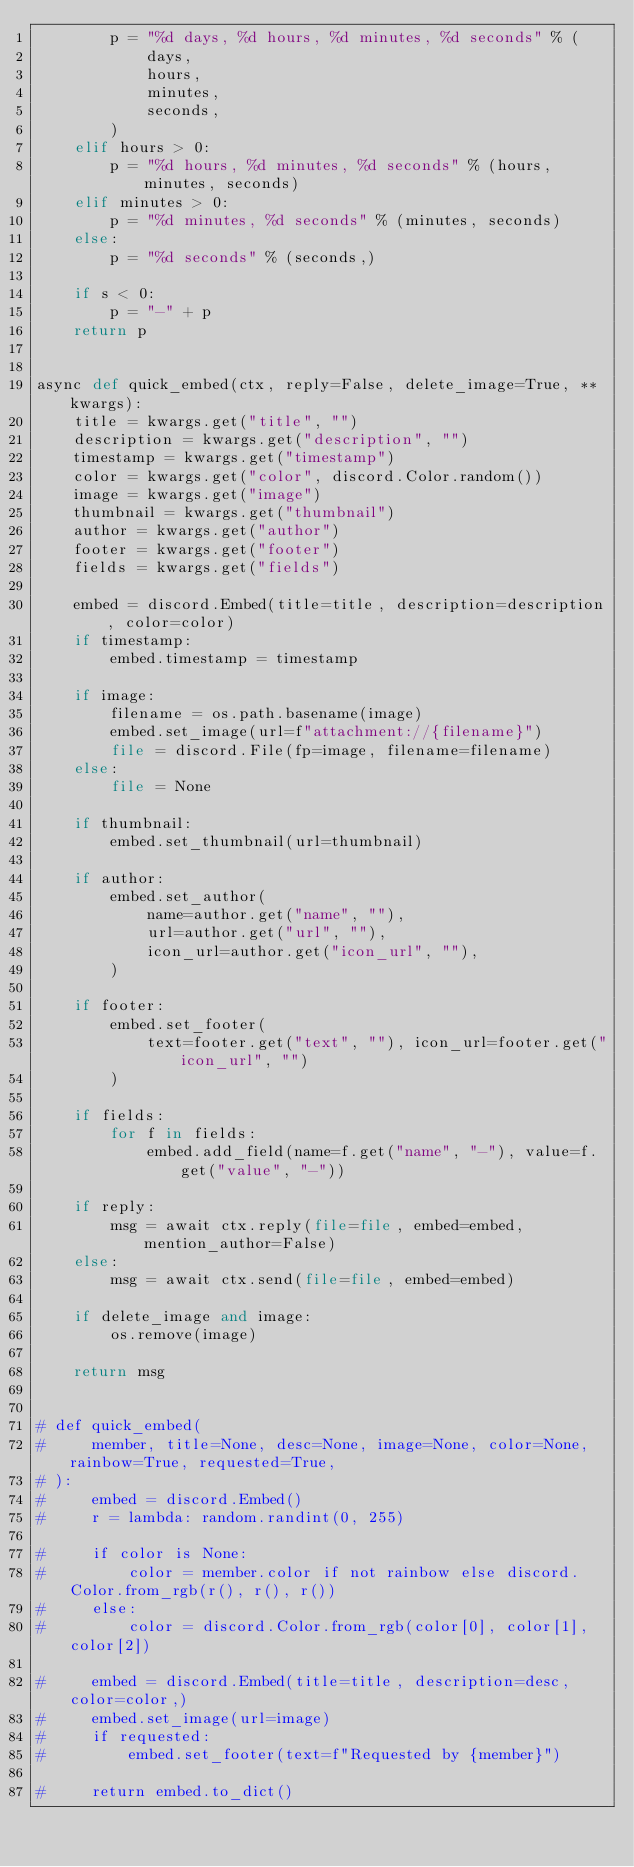<code> <loc_0><loc_0><loc_500><loc_500><_Python_>        p = "%d days, %d hours, %d minutes, %d seconds" % (
            days,
            hours,
            minutes,
            seconds,
        )
    elif hours > 0:
        p = "%d hours, %d minutes, %d seconds" % (hours, minutes, seconds)
    elif minutes > 0:
        p = "%d minutes, %d seconds" % (minutes, seconds)
    else:
        p = "%d seconds" % (seconds,)

    if s < 0:
        p = "-" + p
    return p


async def quick_embed(ctx, reply=False, delete_image=True, **kwargs):
    title = kwargs.get("title", "")
    description = kwargs.get("description", "")
    timestamp = kwargs.get("timestamp")
    color = kwargs.get("color", discord.Color.random())
    image = kwargs.get("image")
    thumbnail = kwargs.get("thumbnail")
    author = kwargs.get("author")
    footer = kwargs.get("footer")
    fields = kwargs.get("fields")

    embed = discord.Embed(title=title, description=description, color=color)
    if timestamp:
        embed.timestamp = timestamp

    if image:
        filename = os.path.basename(image)
        embed.set_image(url=f"attachment://{filename}")
        file = discord.File(fp=image, filename=filename)
    else:
        file = None

    if thumbnail:
        embed.set_thumbnail(url=thumbnail)

    if author:
        embed.set_author(
            name=author.get("name", ""),
            url=author.get("url", ""),
            icon_url=author.get("icon_url", ""),
        )

    if footer:
        embed.set_footer(
            text=footer.get("text", ""), icon_url=footer.get("icon_url", "")
        )

    if fields:
        for f in fields:
            embed.add_field(name=f.get("name", "-"), value=f.get("value", "-"))

    if reply:
        msg = await ctx.reply(file=file, embed=embed, mention_author=False)
    else:
        msg = await ctx.send(file=file, embed=embed)

    if delete_image and image:
        os.remove(image)

    return msg


# def quick_embed(
#     member, title=None, desc=None, image=None, color=None, rainbow=True, requested=True,
# ):
#     embed = discord.Embed()
#     r = lambda: random.randint(0, 255)

#     if color is None:
#         color = member.color if not rainbow else discord.Color.from_rgb(r(), r(), r())
#     else:
#         color = discord.Color.from_rgb(color[0], color[1], color[2])

#     embed = discord.Embed(title=title, description=desc, color=color,)
#     embed.set_image(url=image)
#     if requested:
#         embed.set_footer(text=f"Requested by {member}")

#     return embed.to_dict()

</code> 